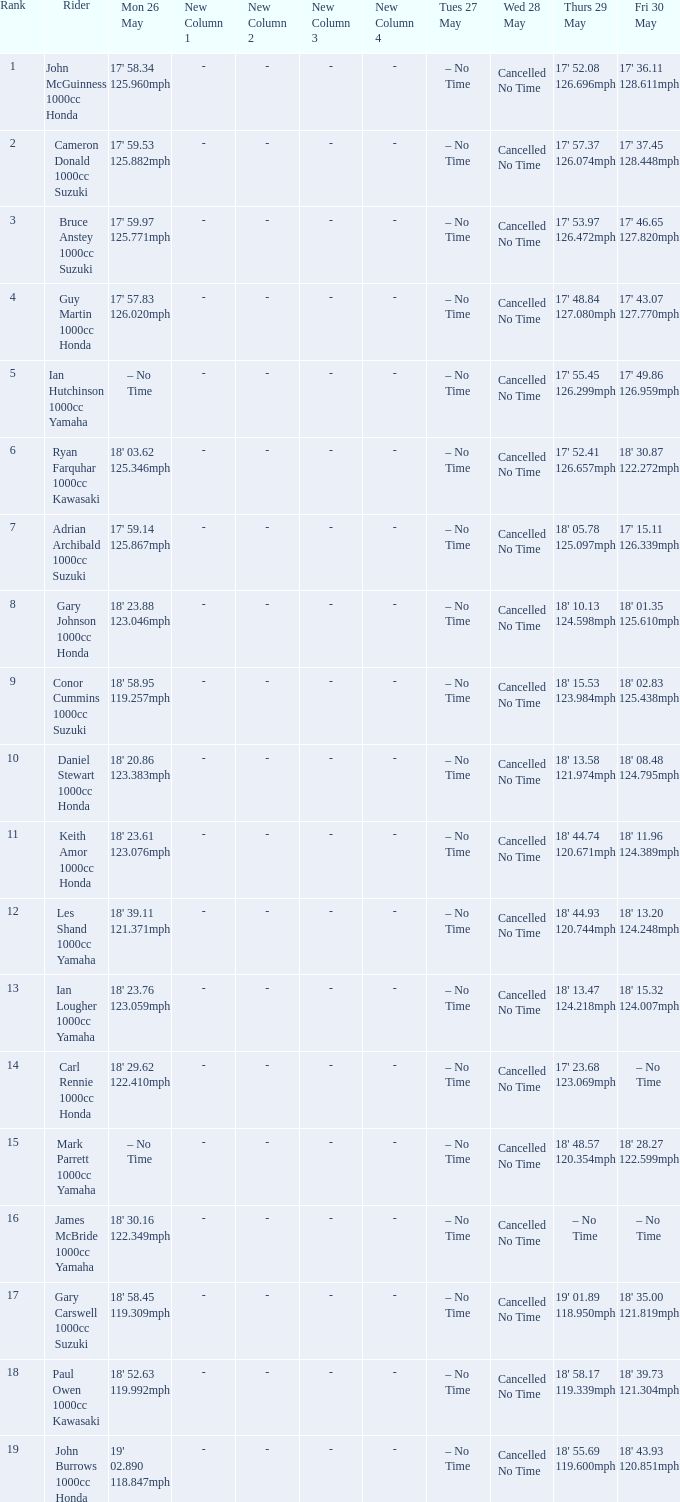Could you help me parse every detail presented in this table? {'header': ['Rank', 'Rider', 'Mon 26 May', 'New Column 1', 'New Column 2', 'New Column 3', 'New Column 4', 'Tues 27 May', 'Wed 28 May', 'Thurs 29 May', 'Fri 30 May'], 'rows': [['1', 'John McGuinness 1000cc Honda', "17' 58.34 125.960mph", '-', '-', '-', '-', '– No Time', 'Cancelled No Time', "17' 52.08 126.696mph", "17' 36.11 128.611mph"], ['2', 'Cameron Donald 1000cc Suzuki', "17' 59.53 125.882mph", '-', '-', '-', '-', '– No Time', 'Cancelled No Time', "17' 57.37 126.074mph", "17' 37.45 128.448mph"], ['3', 'Bruce Anstey 1000cc Suzuki', "17' 59.97 125.771mph", '-', '-', '-', '-', '– No Time', 'Cancelled No Time', "17' 53.97 126.472mph", "17' 46.65 127.820mph"], ['4', 'Guy Martin 1000cc Honda', "17' 57.83 126.020mph", '-', '-', '-', '-', '– No Time', 'Cancelled No Time', "17' 48.84 127.080mph", "17' 43.07 127.770mph"], ['5', 'Ian Hutchinson 1000cc Yamaha', '– No Time', '-', '-', '-', '-', '– No Time', 'Cancelled No Time', "17' 55.45 126.299mph", "17' 49.86 126.959mph"], ['6', 'Ryan Farquhar 1000cc Kawasaki', "18' 03.62 125.346mph", '-', '-', '-', '-', '– No Time', 'Cancelled No Time', "17' 52.41 126.657mph", "18' 30.87 122.272mph"], ['7', 'Adrian Archibald 1000cc Suzuki', "17' 59.14 125.867mph", '-', '-', '-', '-', '– No Time', 'Cancelled No Time', "18' 05.78 125.097mph", "17' 15.11 126.339mph"], ['8', 'Gary Johnson 1000cc Honda', "18' 23.88 123.046mph", '-', '-', '-', '-', '– No Time', 'Cancelled No Time', "18' 10.13 124.598mph", "18' 01.35 125.610mph"], ['9', 'Conor Cummins 1000cc Suzuki', "18' 58.95 119.257mph", '-', '-', '-', '-', '– No Time', 'Cancelled No Time', "18' 15.53 123.984mph", "18' 02.83 125.438mph"], ['10', 'Daniel Stewart 1000cc Honda', "18' 20.86 123.383mph", '-', '-', '-', '-', '– No Time', 'Cancelled No Time', "18' 13.58 121.974mph", "18' 08.48 124.795mph"], ['11', 'Keith Amor 1000cc Honda', "18' 23.61 123.076mph", '-', '-', '-', '-', '– No Time', 'Cancelled No Time', "18' 44.74 120.671mph", "18' 11.96 124.389mph"], ['12', 'Les Shand 1000cc Yamaha', "18' 39.11 121.371mph", '-', '-', '-', '-', '– No Time', 'Cancelled No Time', "18' 44.93 120.744mph", "18' 13.20 124.248mph"], ['13', 'Ian Lougher 1000cc Yamaha', "18' 23.76 123.059mph", '-', '-', '-', '-', '– No Time', 'Cancelled No Time', "18' 13.47 124.218mph", "18' 15.32 124.007mph"], ['14', 'Carl Rennie 1000cc Honda', "18' 29.62 122.410mph", '-', '-', '-', '-', '– No Time', 'Cancelled No Time', "17' 23.68 123.069mph", '– No Time'], ['15', 'Mark Parrett 1000cc Yamaha', '– No Time', '-', '-', '-', '-', '– No Time', 'Cancelled No Time', "18' 48.57 120.354mph", "18' 28.27 122.599mph"], ['16', 'James McBride 1000cc Yamaha', "18' 30.16 122.349mph", '-', '-', '-', '-', '– No Time', 'Cancelled No Time', '– No Time', '– No Time'], ['17', 'Gary Carswell 1000cc Suzuki', "18' 58.45 119.309mph", '-', '-', '-', '-', '– No Time', 'Cancelled No Time', "19' 01.89 118.950mph", "18' 35.00 121.819mph"], ['18', 'Paul Owen 1000cc Kawasaki', "18' 52.63 119.992mph", '-', '-', '-', '-', '– No Time', 'Cancelled No Time', "18' 58.17 119.339mph", "18' 39.73 121.304mph"], ['19', 'John Burrows 1000cc Honda', "19' 02.890 118.847mph", '-', '-', '-', '-', '– No Time', 'Cancelled No Time', "18' 55.69 119.600mph", "18' 43.93 120.851mph"]]} What is the numbr for fri may 30 and mon may 26 is 19' 02.890 118.847mph? 18' 43.93 120.851mph. 